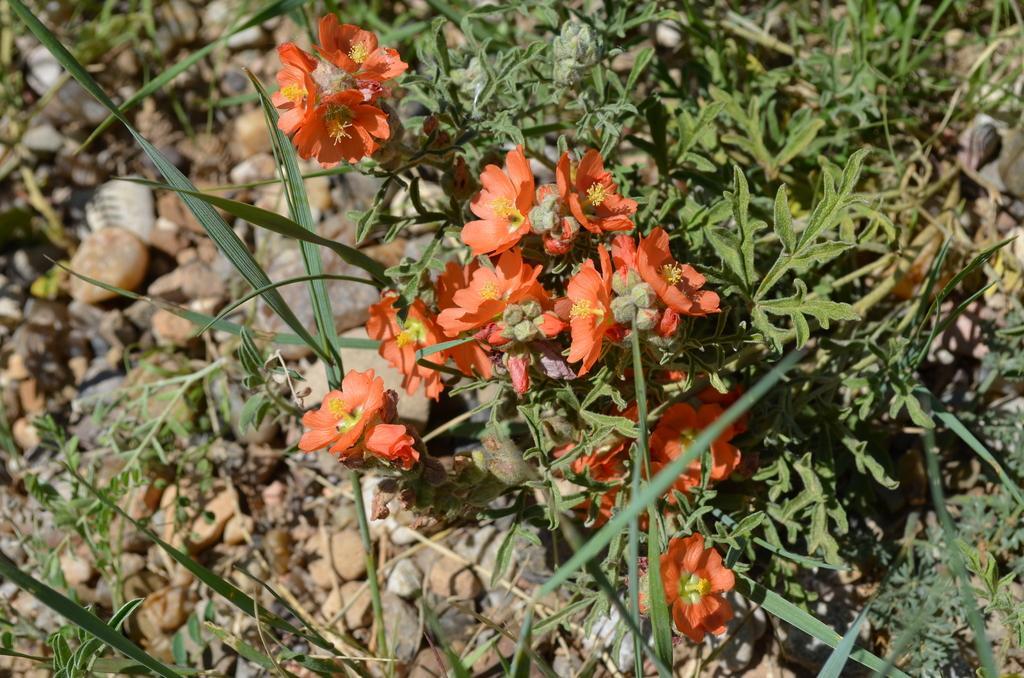In one or two sentences, can you explain what this image depicts? In this image we can see some plants, buds, and plants, also we can see some stones. 